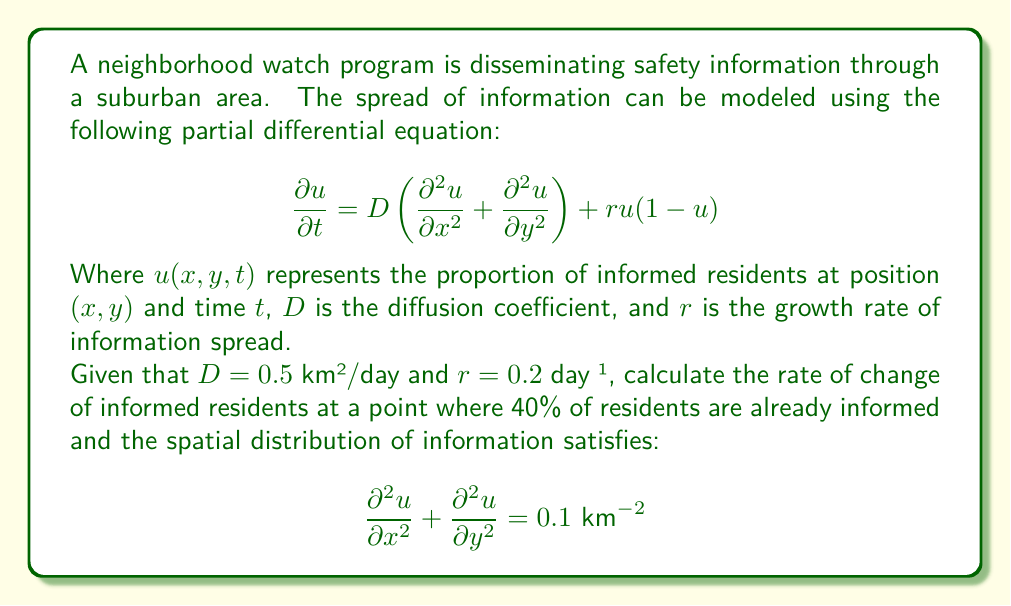Give your solution to this math problem. To solve this problem, we need to use the given partial differential equation and substitute the known values. Let's break it down step by step:

1) The PDE is given as:
   $$\frac{\partial u}{\partial t} = D\left(\frac{\partial^2 u}{\partial x^2} + \frac{\partial^2 u}{\partial y^2}\right) + ru(1-u)$$

2) We are given:
   - $D = 0.5$ km²/day
   - $r = 0.2$ day⁻¹
   - $u = 0.4$ (40% of residents are informed)
   - $\frac{\partial^2 u}{\partial x^2} + \frac{\partial^2 u}{\partial y^2} = 0.1 \text{ km}^{-2}$

3) Let's substitute these values into the PDE:

   $$\frac{\partial u}{\partial t} = 0.5 \cdot 0.1 + 0.2 \cdot 0.4(1-0.4)$$

4) Simplify the right side:
   - First term: $0.5 \cdot 0.1 = 0.05$
   - Second term: $0.2 \cdot 0.4 \cdot 0.6 = 0.048$

5) Sum up the terms:

   $$\frac{\partial u}{\partial t} = 0.05 + 0.048 = 0.098$$

Therefore, the rate of change of informed residents is 0.098 day⁻¹.
Answer: $$\frac{\partial u}{\partial t} = 0.098 \text{ day}^{-1}$$ 